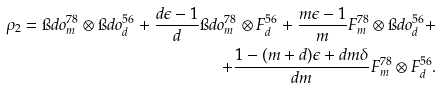<formula> <loc_0><loc_0><loc_500><loc_500>\rho _ { 2 } = \i d o ^ { 7 8 } _ { m } \otimes \i d o ^ { 5 6 } _ { d } + \frac { d \epsilon - 1 } { d } \i d o ^ { 7 8 } _ { m } \otimes F ^ { 5 6 } _ { d } + \frac { m \epsilon - 1 } { m } F ^ { 7 8 } _ { m } \otimes \i d o ^ { 5 6 } _ { d } + \\ + \frac { 1 - ( m + d ) \epsilon + d m \delta } { d m } F ^ { 7 8 } _ { m } \otimes F ^ { 5 6 } _ { d } .</formula> 